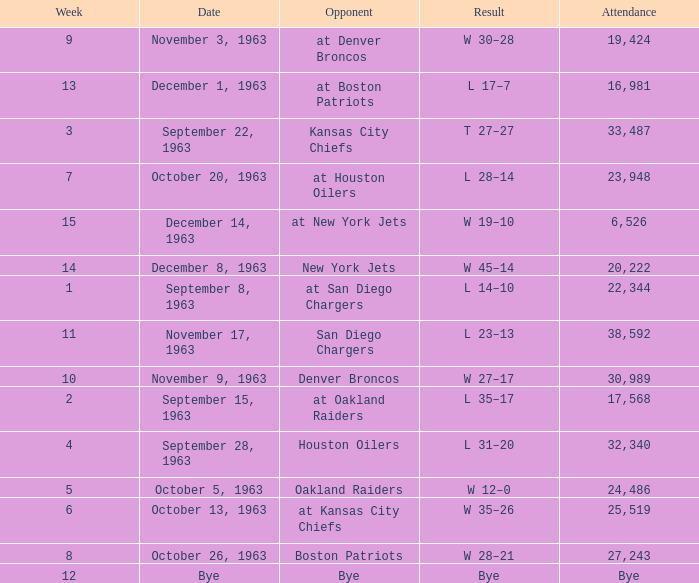Which Result has a Week smaller than 11, and Attendance of 17,568? L 35–17. 